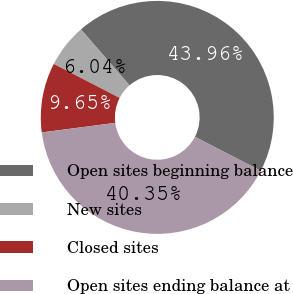Convert chart. <chart><loc_0><loc_0><loc_500><loc_500><pie_chart><fcel>Open sites beginning balance<fcel>New sites<fcel>Closed sites<fcel>Open sites ending balance at<nl><fcel>43.96%<fcel>6.04%<fcel>9.65%<fcel>40.35%<nl></chart> 